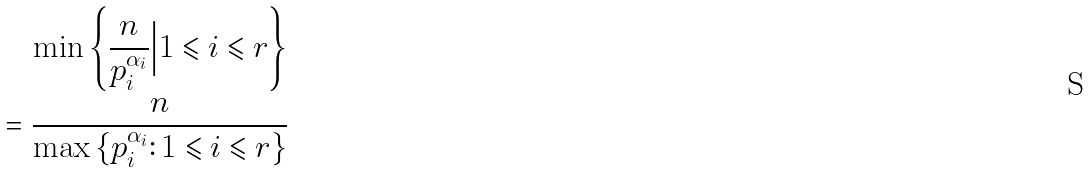<formula> <loc_0><loc_0><loc_500><loc_500>& \quad \min \left \{ \frac { n } { p _ { i } ^ { \alpha _ { i } } } \Big | 1 \leqslant i \leqslant r \right \} \\ & = \frac { n } { \max \left \{ p _ { i } ^ { \alpha _ { i } } \colon 1 \leqslant i \leqslant r \right \} }</formula> 